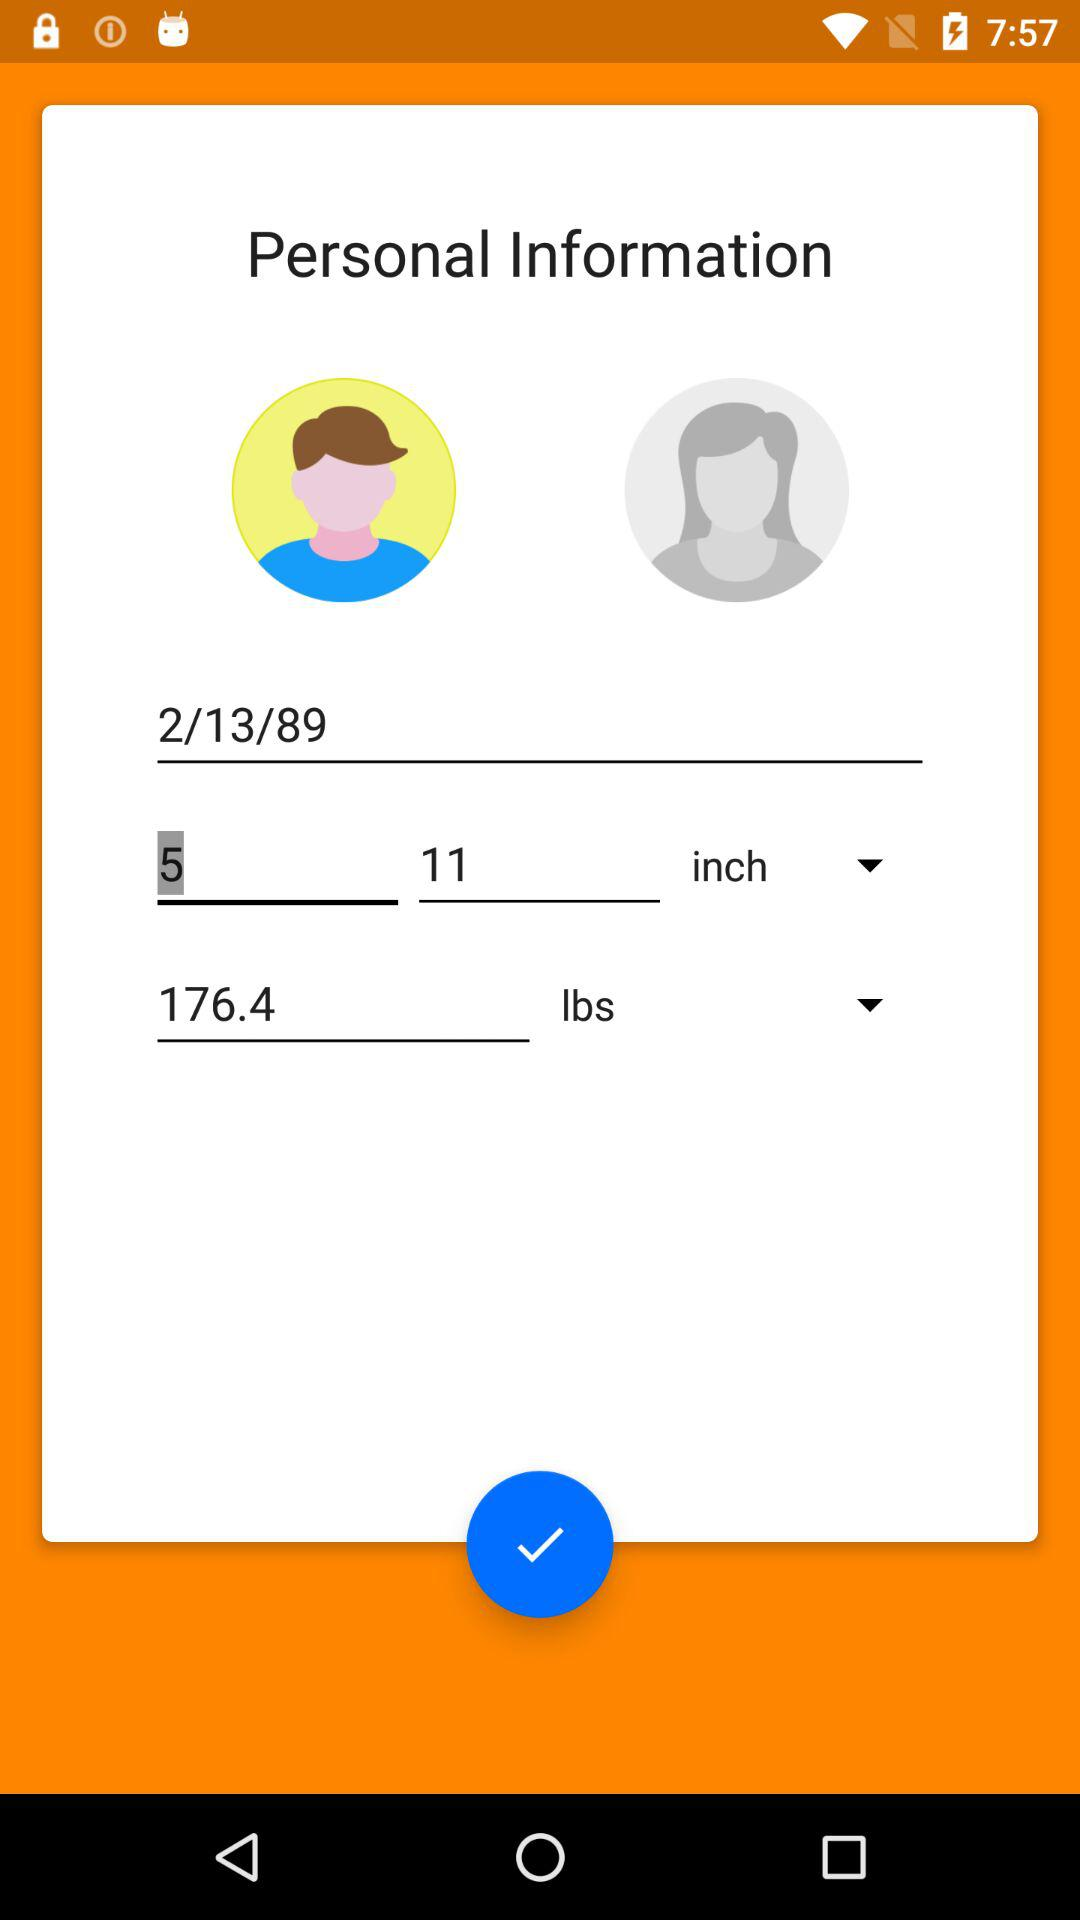What is the date of birth? The date of birth is February 13, 1989. 